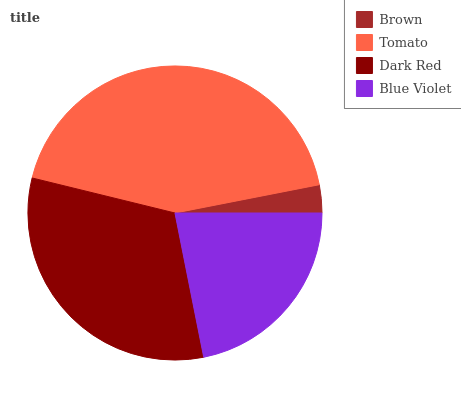Is Brown the minimum?
Answer yes or no. Yes. Is Tomato the maximum?
Answer yes or no. Yes. Is Dark Red the minimum?
Answer yes or no. No. Is Dark Red the maximum?
Answer yes or no. No. Is Tomato greater than Dark Red?
Answer yes or no. Yes. Is Dark Red less than Tomato?
Answer yes or no. Yes. Is Dark Red greater than Tomato?
Answer yes or no. No. Is Tomato less than Dark Red?
Answer yes or no. No. Is Dark Red the high median?
Answer yes or no. Yes. Is Blue Violet the low median?
Answer yes or no. Yes. Is Blue Violet the high median?
Answer yes or no. No. Is Tomato the low median?
Answer yes or no. No. 